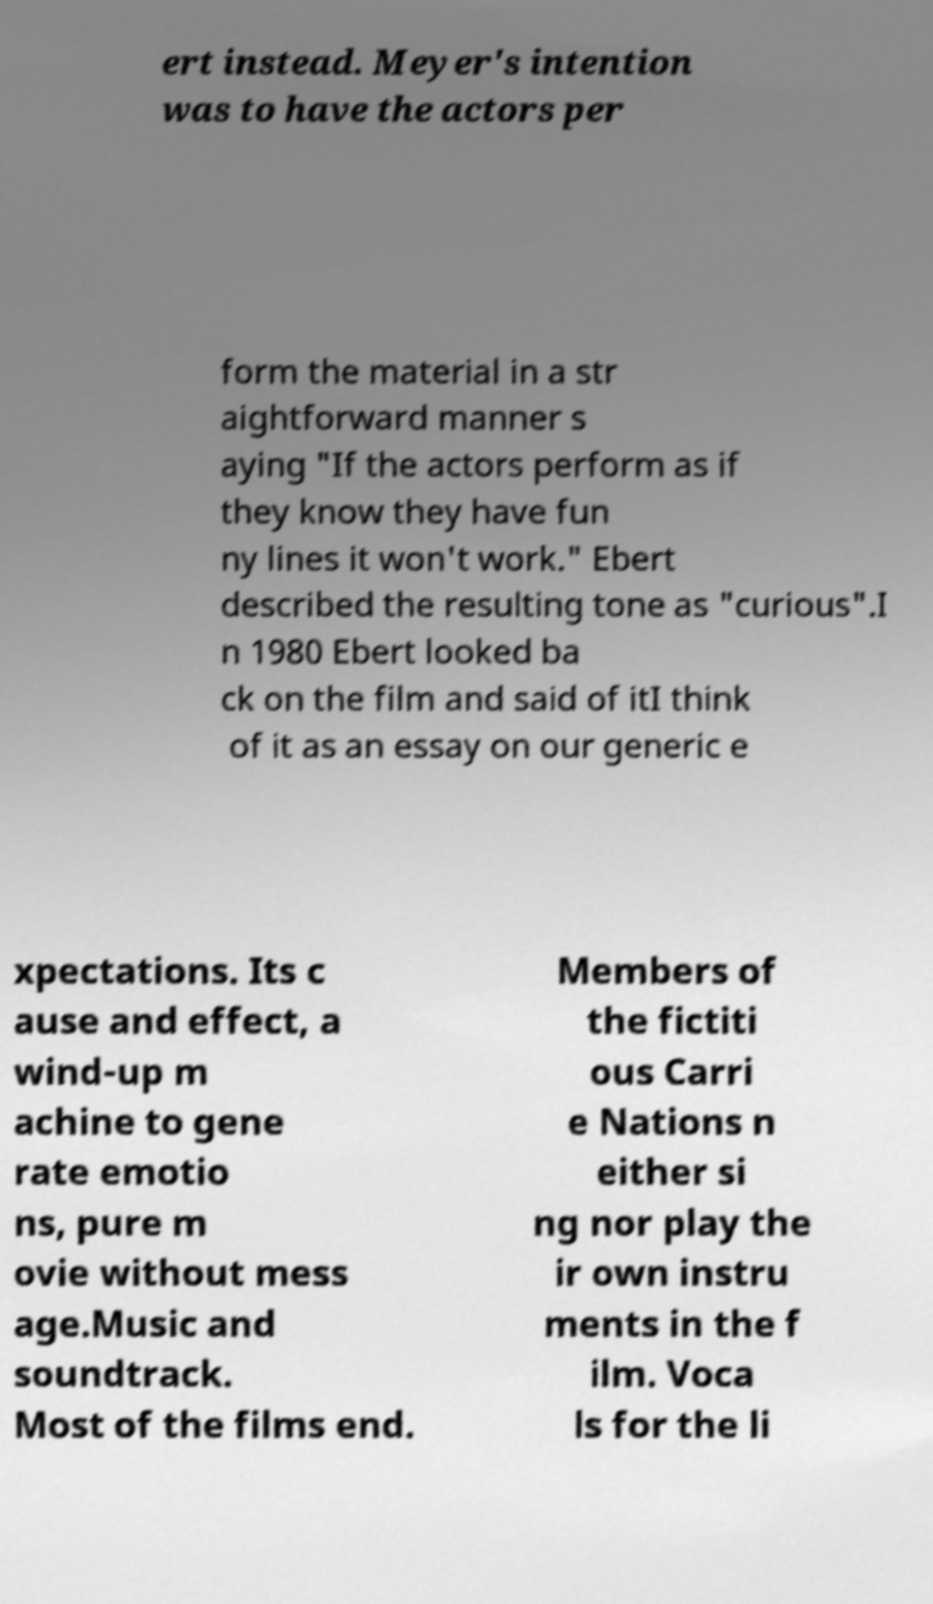There's text embedded in this image that I need extracted. Can you transcribe it verbatim? ert instead. Meyer's intention was to have the actors per form the material in a str aightforward manner s aying "If the actors perform as if they know they have fun ny lines it won't work." Ebert described the resulting tone as "curious".I n 1980 Ebert looked ba ck on the film and said of itI think of it as an essay on our generic e xpectations. Its c ause and effect, a wind-up m achine to gene rate emotio ns, pure m ovie without mess age.Music and soundtrack. Most of the films end. Members of the fictiti ous Carri e Nations n either si ng nor play the ir own instru ments in the f ilm. Voca ls for the li 